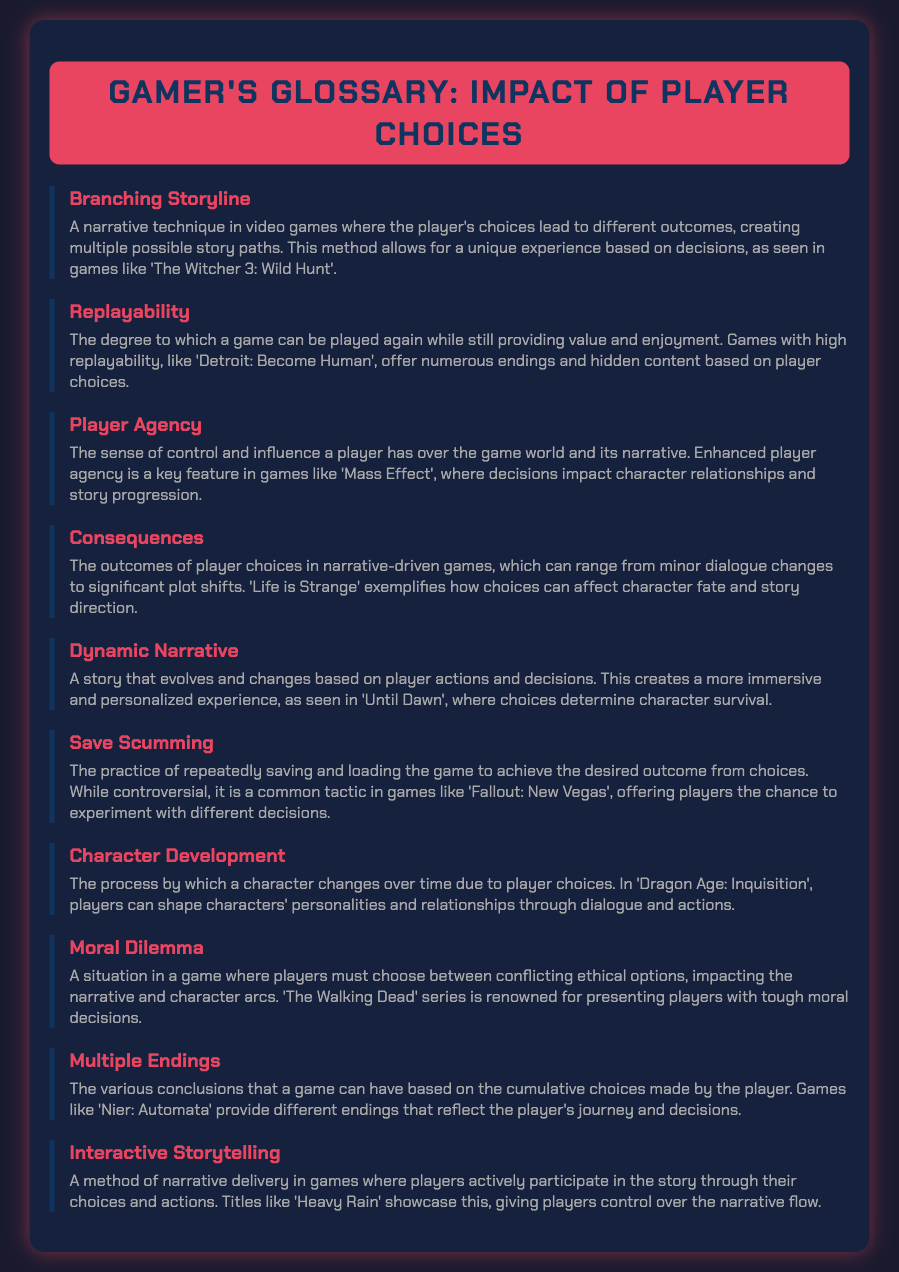What is a narrative technique that leads to different outcomes? The document describes a technique that allows for multiple story paths based on player choices, known as Branching Storyline.
Answer: Branching Storyline Which game is mentioned as an example of high replayability? The glossary states that 'Detroit: Become Human' is a game known for its high replayability due to numerous endings.
Answer: Detroit: Become Human What term refers to the sense of control a player has in a game? Player Agency is defined in the document as the sense of control a player has over the game world and its narrative.
Answer: Player Agency Which game exemplifies how player choices can affect character fate? The glossary highlights 'Life is Strange' as an example of a game where choices significantly impact character fate and story direction.
Answer: Life is Strange What is the term for the practice of saving and loading to achieve desired outcomes? The document introduces the practice known as Save Scumming, where players repeatedly save and load to get better results from their choices.
Answer: Save Scumming How does 'Dragon Age: Inquisition' relate to character changes? The game 'Dragon Age: Inquisition' is used as an example of how player choices affect character development over time.
Answer: Character Development What does the term Moral Dilemma refer to in gaming? A Moral Dilemma is described as a situation where players must choose between conflicting ethical options affecting the narrative.
Answer: Moral Dilemma What kind of endings can a game like 'Nier: Automata' have? The document states that games like 'Nier: Automata' can have Multiple Endings based on player choices.
Answer: Multiple Endings What narrative delivery method allows players to shape the story? The glossary uses the term Interactive Storytelling to describe the method where players participate in the story through their choices.
Answer: Interactive Storytelling 